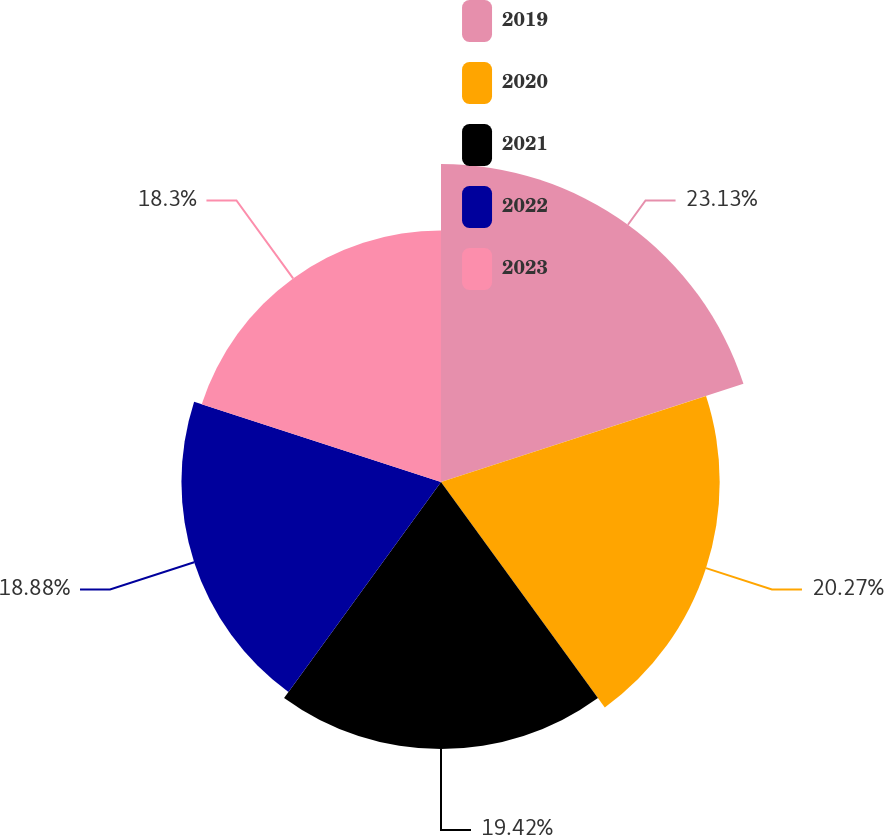Convert chart. <chart><loc_0><loc_0><loc_500><loc_500><pie_chart><fcel>2019<fcel>2020<fcel>2021<fcel>2022<fcel>2023<nl><fcel>23.13%<fcel>20.27%<fcel>19.42%<fcel>18.88%<fcel>18.3%<nl></chart> 